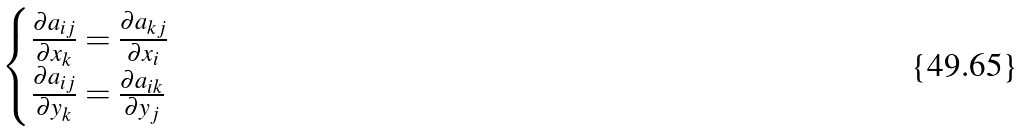Convert formula to latex. <formula><loc_0><loc_0><loc_500><loc_500>\begin{cases} \frac { \partial a _ { i j } } { \partial x _ { k } } = \frac { \partial a _ { k j } } { \partial x _ { i } } & \\ \frac { \partial a _ { i j } } { \partial y _ { k } } = \frac { \partial a _ { i k } } { \partial y _ { j } } & \\ \end{cases}</formula> 